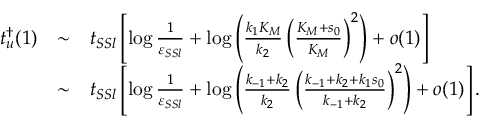<formula> <loc_0><loc_0><loc_500><loc_500>\begin{array} { r c l } { t _ { u } ^ { \dagger } ( 1 ) } & { \sim } & { t _ { S S l } \left [ \log \frac { 1 } { \varepsilon _ { S S l } } + \log \left ( \frac { k _ { 1 } K _ { M } } { k _ { 2 } } \left ( \frac { K _ { M } + s _ { 0 } } { K _ { M } } \right ) ^ { 2 } \right ) + o ( 1 ) \right ] } \\ & { \sim } & { t _ { S S l } \left [ \log \frac { 1 } { \varepsilon _ { S S l } } + \log \left ( \frac { k _ { - 1 } + k _ { 2 } } { k _ { 2 } } \left ( \frac { k _ { - 1 } + k _ { 2 } + k _ { 1 } s _ { 0 } } { k _ { - 1 } + k _ { 2 } } \right ) ^ { 2 } \right ) + o ( 1 ) \right ] . } \end{array}</formula> 